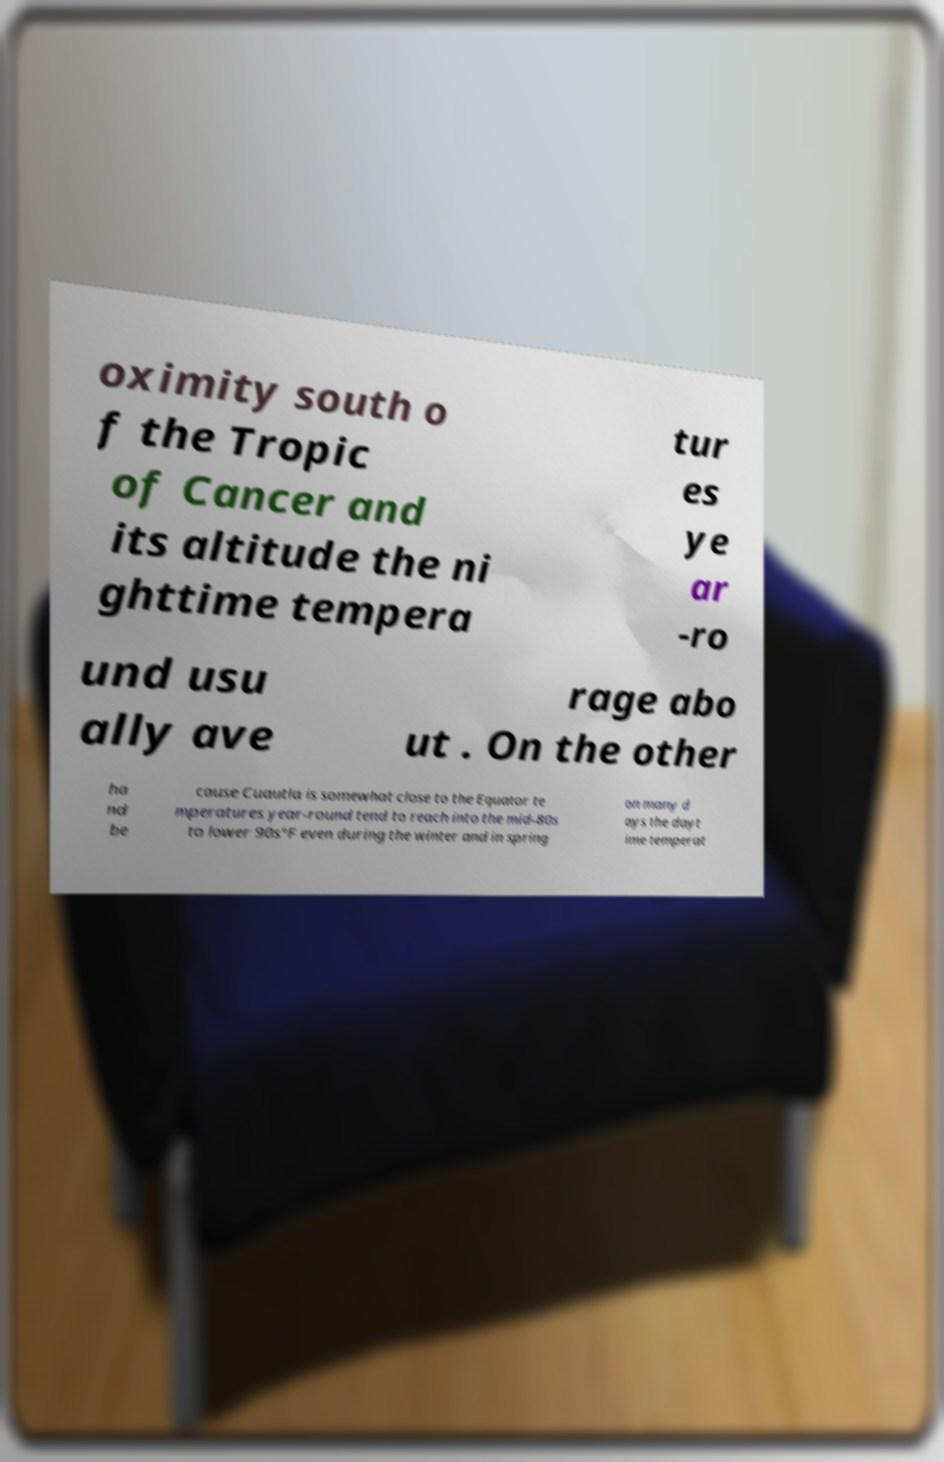There's text embedded in this image that I need extracted. Can you transcribe it verbatim? oximity south o f the Tropic of Cancer and its altitude the ni ghttime tempera tur es ye ar -ro und usu ally ave rage abo ut . On the other ha nd be cause Cuautla is somewhat close to the Equator te mperatures year-round tend to reach into the mid-80s to lower 90s°F even during the winter and in spring on many d ays the dayt ime temperat 